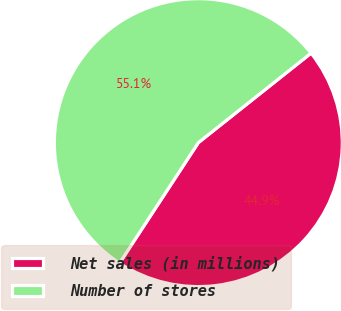Convert chart. <chart><loc_0><loc_0><loc_500><loc_500><pie_chart><fcel>Net sales (in millions)<fcel>Number of stores<nl><fcel>44.9%<fcel>55.1%<nl></chart> 